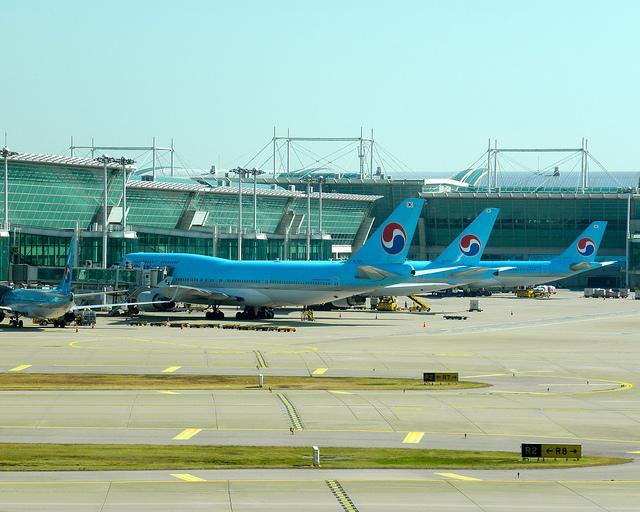The symbol on the planes looks like what logo?

Choices:
A) pepsi
B) mcdonald's
C) starbucks
D) nbc pepsi 